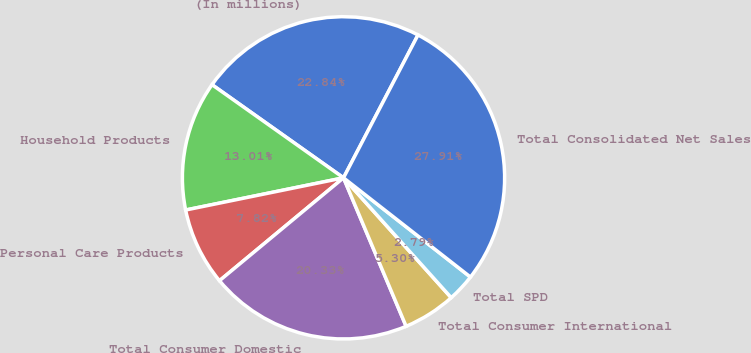Convert chart. <chart><loc_0><loc_0><loc_500><loc_500><pie_chart><fcel>(In millions)<fcel>Household Products<fcel>Personal Care Products<fcel>Total Consumer Domestic<fcel>Total Consumer International<fcel>Total SPD<fcel>Total Consolidated Net Sales<nl><fcel>22.84%<fcel>13.01%<fcel>7.82%<fcel>20.33%<fcel>5.3%<fcel>2.79%<fcel>27.91%<nl></chart> 